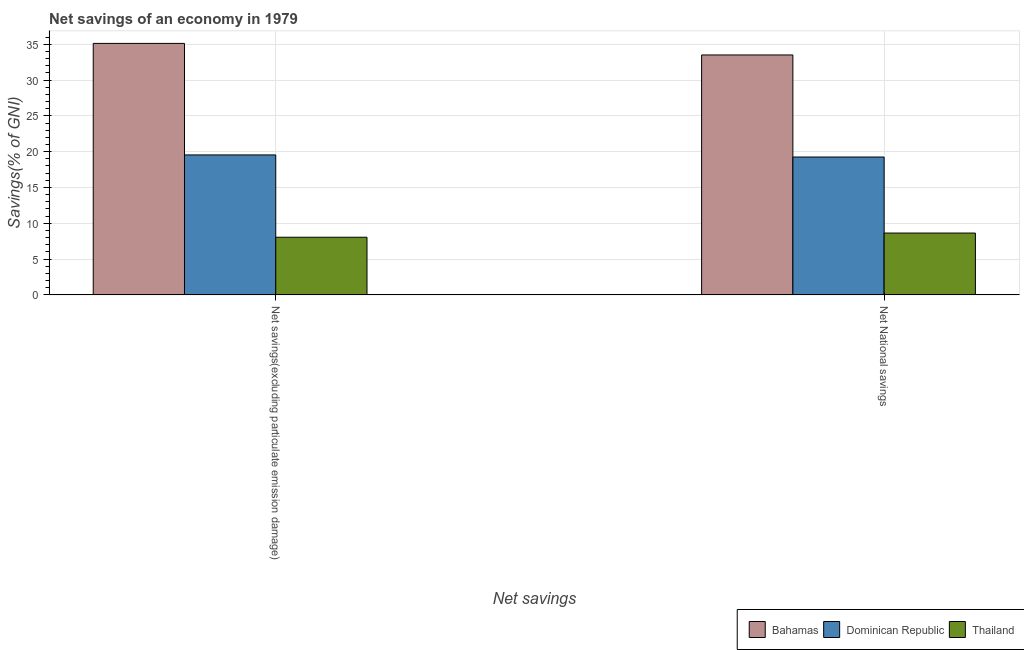How many groups of bars are there?
Provide a short and direct response. 2. Are the number of bars on each tick of the X-axis equal?
Your answer should be very brief. Yes. What is the label of the 1st group of bars from the left?
Make the answer very short. Net savings(excluding particulate emission damage). What is the net savings(excluding particulate emission damage) in Thailand?
Offer a terse response. 8.05. Across all countries, what is the maximum net national savings?
Your response must be concise. 33.5. Across all countries, what is the minimum net national savings?
Give a very brief answer. 8.63. In which country was the net national savings maximum?
Give a very brief answer. Bahamas. In which country was the net savings(excluding particulate emission damage) minimum?
Offer a very short reply. Thailand. What is the total net national savings in the graph?
Your answer should be compact. 61.39. What is the difference between the net national savings in Dominican Republic and that in Bahamas?
Keep it short and to the point. -14.25. What is the difference between the net savings(excluding particulate emission damage) in Thailand and the net national savings in Bahamas?
Offer a very short reply. -25.45. What is the average net national savings per country?
Your answer should be compact. 20.46. What is the difference between the net savings(excluding particulate emission damage) and net national savings in Dominican Republic?
Provide a short and direct response. 0.29. In how many countries, is the net savings(excluding particulate emission damage) greater than 26 %?
Give a very brief answer. 1. What is the ratio of the net savings(excluding particulate emission damage) in Bahamas to that in Thailand?
Ensure brevity in your answer.  4.36. In how many countries, is the net savings(excluding particulate emission damage) greater than the average net savings(excluding particulate emission damage) taken over all countries?
Give a very brief answer. 1. What does the 1st bar from the left in Net savings(excluding particulate emission damage) represents?
Offer a terse response. Bahamas. What does the 2nd bar from the right in Net savings(excluding particulate emission damage) represents?
Keep it short and to the point. Dominican Republic. How many countries are there in the graph?
Provide a succinct answer. 3. What is the difference between two consecutive major ticks on the Y-axis?
Offer a terse response. 5. Are the values on the major ticks of Y-axis written in scientific E-notation?
Keep it short and to the point. No. How are the legend labels stacked?
Ensure brevity in your answer.  Horizontal. What is the title of the graph?
Provide a succinct answer. Net savings of an economy in 1979. Does "Estonia" appear as one of the legend labels in the graph?
Keep it short and to the point. No. What is the label or title of the X-axis?
Make the answer very short. Net savings. What is the label or title of the Y-axis?
Your answer should be very brief. Savings(% of GNI). What is the Savings(% of GNI) in Bahamas in Net savings(excluding particulate emission damage)?
Keep it short and to the point. 35.12. What is the Savings(% of GNI) of Dominican Republic in Net savings(excluding particulate emission damage)?
Offer a very short reply. 19.54. What is the Savings(% of GNI) of Thailand in Net savings(excluding particulate emission damage)?
Your answer should be compact. 8.05. What is the Savings(% of GNI) of Bahamas in Net National savings?
Provide a succinct answer. 33.5. What is the Savings(% of GNI) in Dominican Republic in Net National savings?
Give a very brief answer. 19.25. What is the Savings(% of GNI) of Thailand in Net National savings?
Provide a short and direct response. 8.63. Across all Net savings, what is the maximum Savings(% of GNI) in Bahamas?
Ensure brevity in your answer.  35.12. Across all Net savings, what is the maximum Savings(% of GNI) of Dominican Republic?
Make the answer very short. 19.54. Across all Net savings, what is the maximum Savings(% of GNI) of Thailand?
Ensure brevity in your answer.  8.63. Across all Net savings, what is the minimum Savings(% of GNI) in Bahamas?
Keep it short and to the point. 33.5. Across all Net savings, what is the minimum Savings(% of GNI) of Dominican Republic?
Your answer should be very brief. 19.25. Across all Net savings, what is the minimum Savings(% of GNI) of Thailand?
Give a very brief answer. 8.05. What is the total Savings(% of GNI) of Bahamas in the graph?
Your response must be concise. 68.62. What is the total Savings(% of GNI) of Dominican Republic in the graph?
Keep it short and to the point. 38.8. What is the total Savings(% of GNI) in Thailand in the graph?
Provide a short and direct response. 16.68. What is the difference between the Savings(% of GNI) of Bahamas in Net savings(excluding particulate emission damage) and that in Net National savings?
Provide a succinct answer. 1.61. What is the difference between the Savings(% of GNI) in Dominican Republic in Net savings(excluding particulate emission damage) and that in Net National savings?
Provide a short and direct response. 0.29. What is the difference between the Savings(% of GNI) in Thailand in Net savings(excluding particulate emission damage) and that in Net National savings?
Ensure brevity in your answer.  -0.58. What is the difference between the Savings(% of GNI) in Bahamas in Net savings(excluding particulate emission damage) and the Savings(% of GNI) in Dominican Republic in Net National savings?
Provide a succinct answer. 15.87. What is the difference between the Savings(% of GNI) of Bahamas in Net savings(excluding particulate emission damage) and the Savings(% of GNI) of Thailand in Net National savings?
Provide a succinct answer. 26.48. What is the difference between the Savings(% of GNI) in Dominican Republic in Net savings(excluding particulate emission damage) and the Savings(% of GNI) in Thailand in Net National savings?
Your response must be concise. 10.91. What is the average Savings(% of GNI) of Bahamas per Net savings?
Your response must be concise. 34.31. What is the average Savings(% of GNI) of Dominican Republic per Net savings?
Ensure brevity in your answer.  19.4. What is the average Savings(% of GNI) in Thailand per Net savings?
Provide a short and direct response. 8.34. What is the difference between the Savings(% of GNI) of Bahamas and Savings(% of GNI) of Dominican Republic in Net savings(excluding particulate emission damage)?
Make the answer very short. 15.57. What is the difference between the Savings(% of GNI) in Bahamas and Savings(% of GNI) in Thailand in Net savings(excluding particulate emission damage)?
Offer a very short reply. 27.07. What is the difference between the Savings(% of GNI) of Dominican Republic and Savings(% of GNI) of Thailand in Net savings(excluding particulate emission damage)?
Offer a very short reply. 11.5. What is the difference between the Savings(% of GNI) in Bahamas and Savings(% of GNI) in Dominican Republic in Net National savings?
Give a very brief answer. 14.25. What is the difference between the Savings(% of GNI) of Bahamas and Savings(% of GNI) of Thailand in Net National savings?
Provide a succinct answer. 24.87. What is the difference between the Savings(% of GNI) in Dominican Republic and Savings(% of GNI) in Thailand in Net National savings?
Make the answer very short. 10.62. What is the ratio of the Savings(% of GNI) in Bahamas in Net savings(excluding particulate emission damage) to that in Net National savings?
Your response must be concise. 1.05. What is the ratio of the Savings(% of GNI) in Dominican Republic in Net savings(excluding particulate emission damage) to that in Net National savings?
Keep it short and to the point. 1.02. What is the ratio of the Savings(% of GNI) of Thailand in Net savings(excluding particulate emission damage) to that in Net National savings?
Keep it short and to the point. 0.93. What is the difference between the highest and the second highest Savings(% of GNI) in Bahamas?
Offer a very short reply. 1.61. What is the difference between the highest and the second highest Savings(% of GNI) in Dominican Republic?
Give a very brief answer. 0.29. What is the difference between the highest and the second highest Savings(% of GNI) in Thailand?
Your answer should be compact. 0.58. What is the difference between the highest and the lowest Savings(% of GNI) of Bahamas?
Keep it short and to the point. 1.61. What is the difference between the highest and the lowest Savings(% of GNI) in Dominican Republic?
Make the answer very short. 0.29. What is the difference between the highest and the lowest Savings(% of GNI) in Thailand?
Your answer should be very brief. 0.58. 